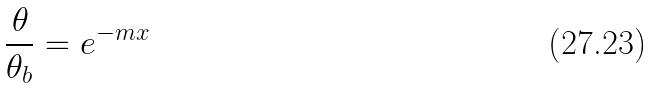<formula> <loc_0><loc_0><loc_500><loc_500>\frac { \theta } { \theta _ { b } } = e ^ { - m x }</formula> 